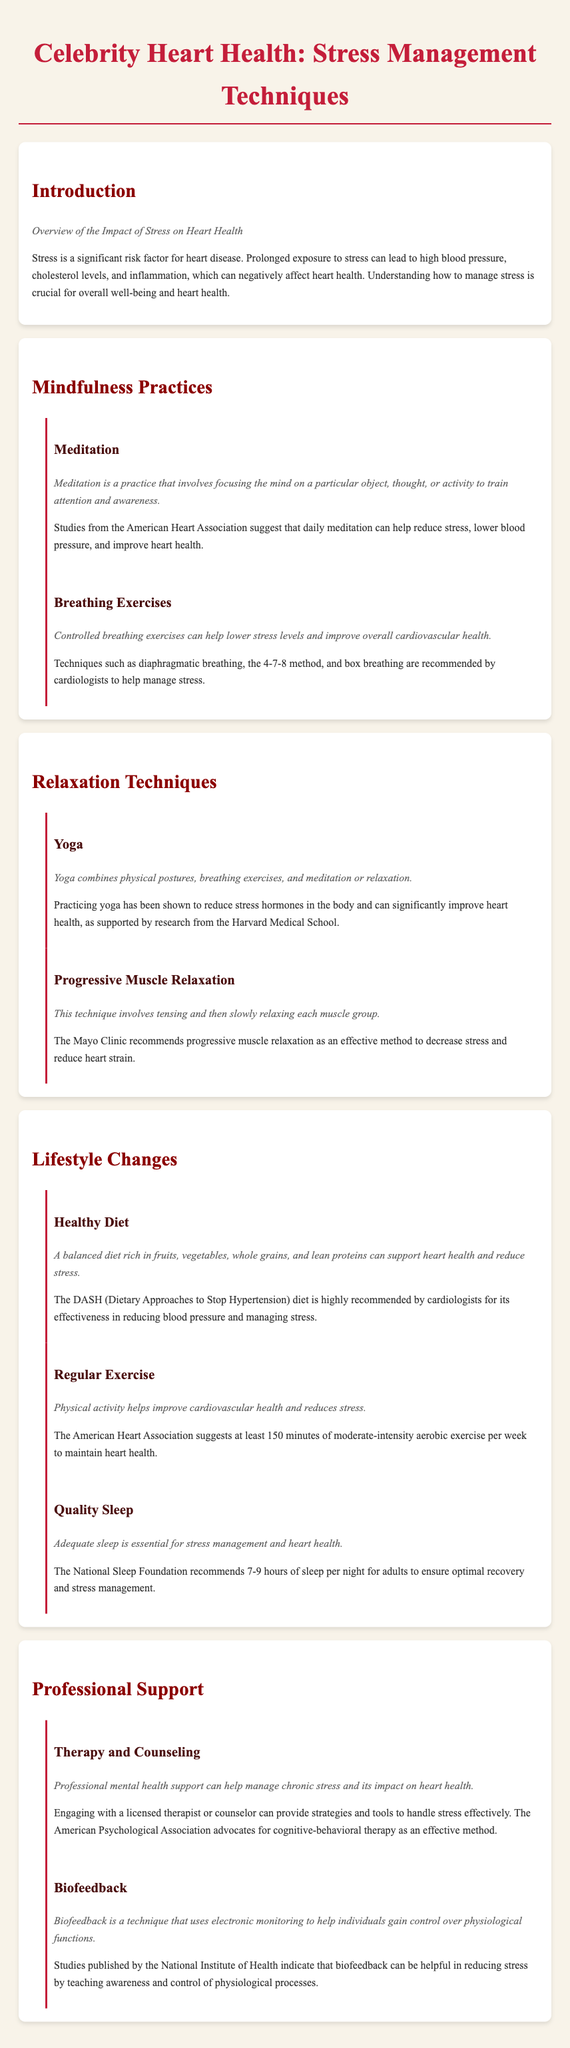What is the title of the document? The title of the document is displayed prominently at the top of the page.
Answer: Celebrity Heart Health: Stress Management Techniques What practice is associated with reducing stress according to the American Heart Association? The document mentions a specific practice that is recommended by the American Heart Association for reducing stress.
Answer: Meditation What is one recommended breathing method to manage stress? The document lists specific breathing techniques suggested by cardiologists for stress management.
Answer: 4-7-8 method How many minutes of exercise are suggested per week by the American Heart Association? The document provides a recommendation for the amount of weekly exercise to maintain heart health.
Answer: 150 minutes Which relaxation technique is supported by research from Harvard Medical School? The document indicates a specific relaxation practice that has research backing from a reputable institution.
Answer: Yoga What does the DASH diet aim to reduce? The document highlights the goal of the DASH diet specifically in relation to health.
Answer: Blood pressure What is the recommended sleep duration for adults according to the National Sleep Foundation? The document provides a guideline for adequate sleep duration to ensure optimal recovery and stress management.
Answer: 7-9 hours Which professional support is suggested for managing chronic stress? The document suggests a specific type of professional support that could help in managing chronic stress effectively.
Answer: Therapy and Counseling What technique uses electronic monitoring for gaining control over physiological functions? The document describes a specific method that employs technology for stress management.
Answer: Biofeedback 